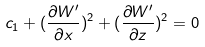Convert formula to latex. <formula><loc_0><loc_0><loc_500><loc_500>c _ { 1 } + ( \frac { { \partial } W ^ { \prime } } { { \partial } x } ) ^ { 2 } + ( \frac { { \partial } W ^ { \prime } } { { \partial } z } ) ^ { 2 } = 0</formula> 